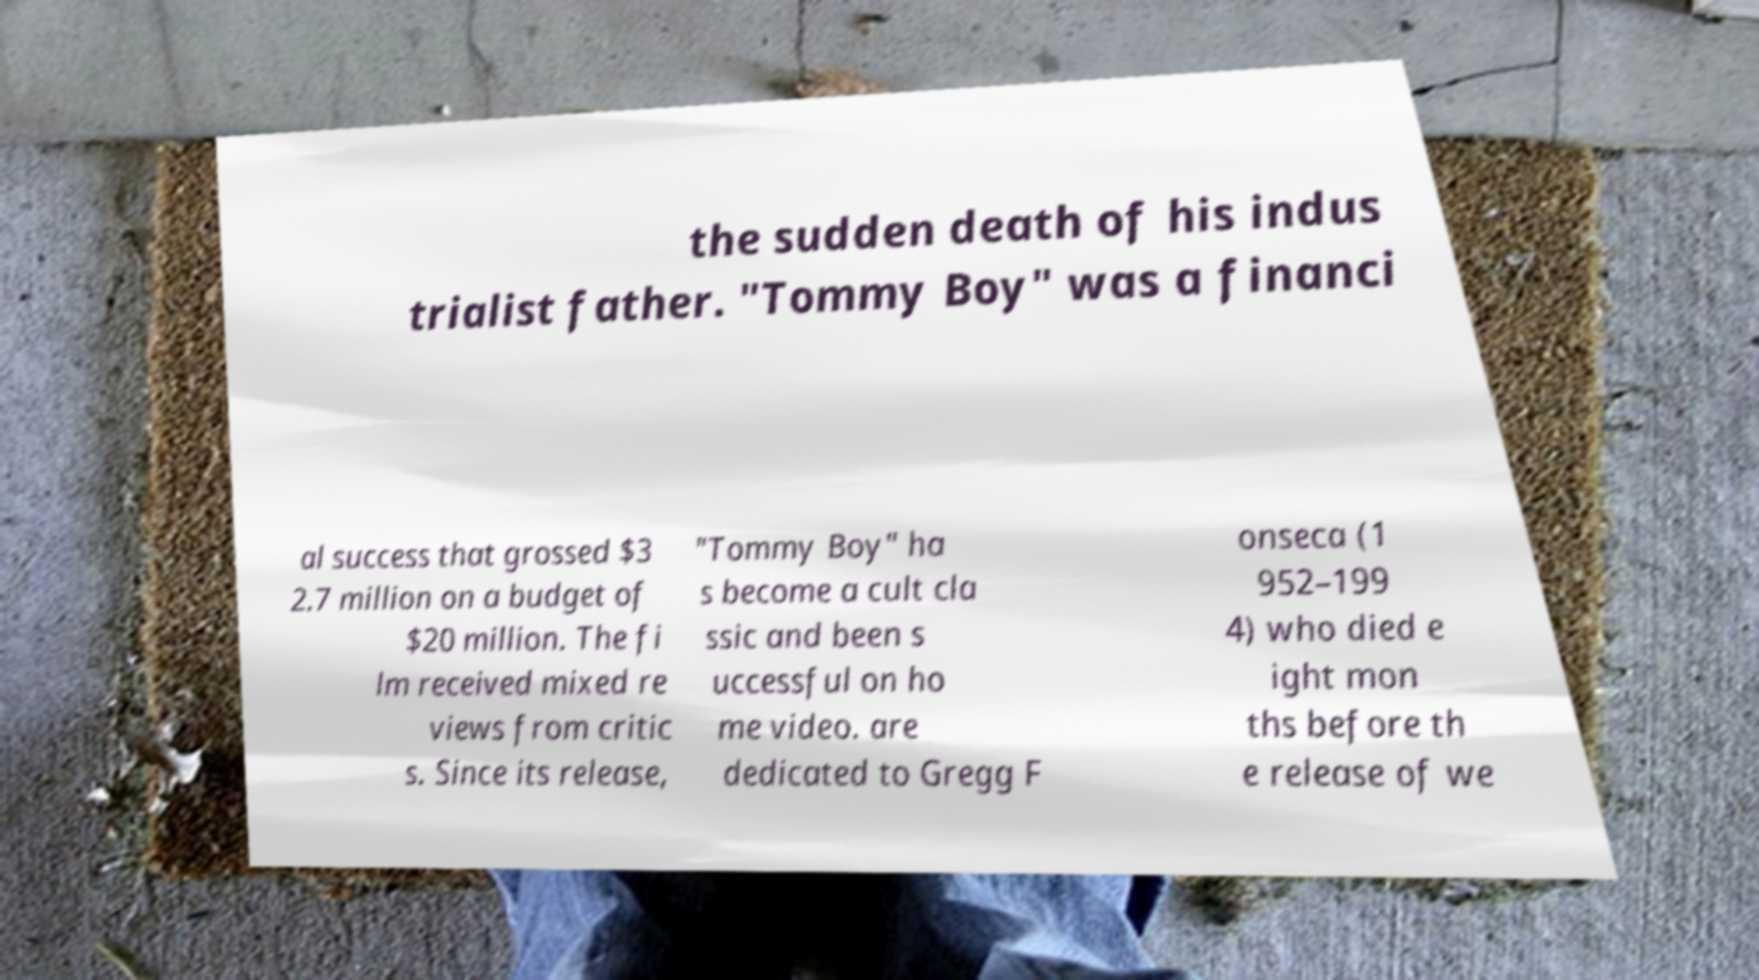Could you assist in decoding the text presented in this image and type it out clearly? the sudden death of his indus trialist father. "Tommy Boy" was a financi al success that grossed $3 2.7 million on a budget of $20 million. The fi lm received mixed re views from critic s. Since its release, "Tommy Boy" ha s become a cult cla ssic and been s uccessful on ho me video. are dedicated to Gregg F onseca (1 952–199 4) who died e ight mon ths before th e release of we 